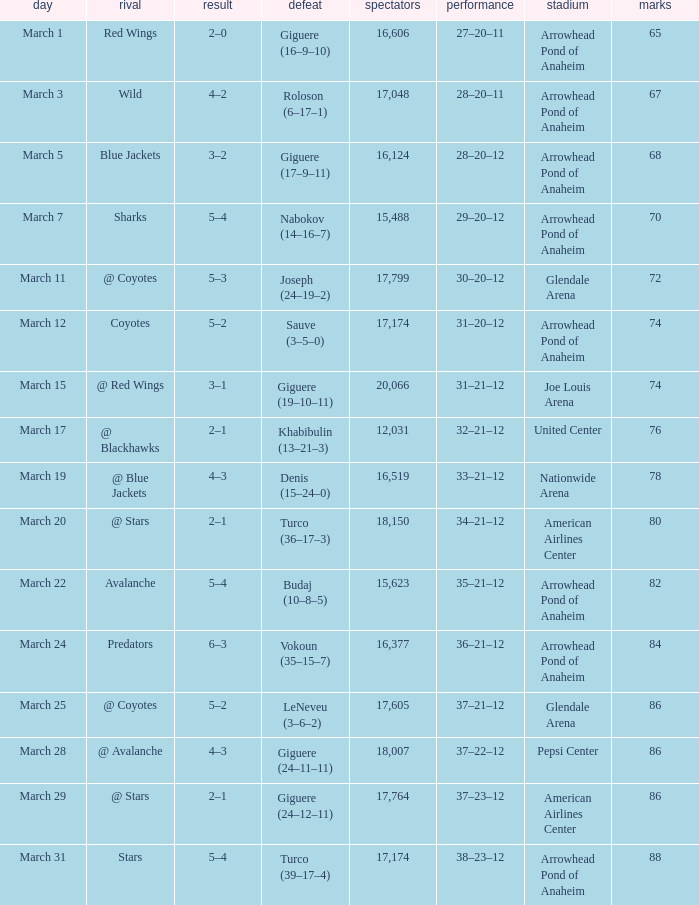What is the Score of the game on March 19? 4–3. 